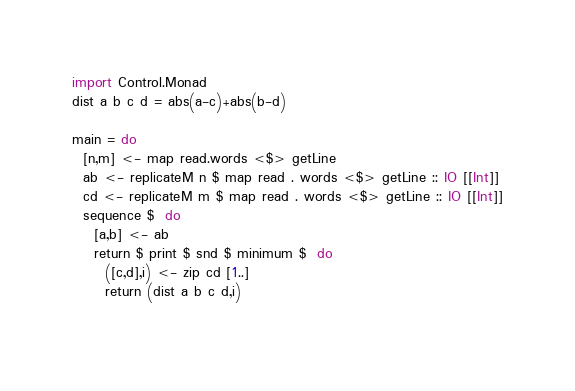Convert code to text. <code><loc_0><loc_0><loc_500><loc_500><_Haskell_>import Control.Monad
dist a b c d = abs(a-c)+abs(b-d)

main = do
  [n,m] <- map read.words <$> getLine 
  ab <- replicateM n $ map read . words <$> getLine :: IO [[Int]]
  cd <- replicateM m $ map read . words <$> getLine :: IO [[Int]]
  sequence $  do 
    [a,b] <- ab
    return $ print $ snd $ minimum $  do 
      ([c,d],i) <- zip cd [1..]
      return (dist a b c d,i)
    
</code> 